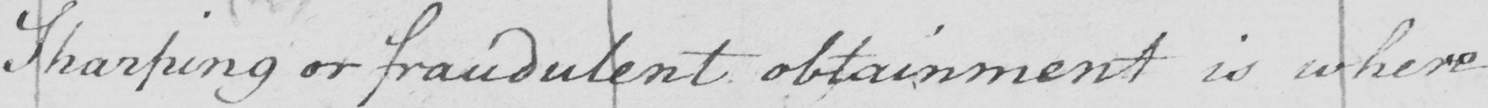What text is written in this handwritten line? Sharping or fraudulent obtainment is where 